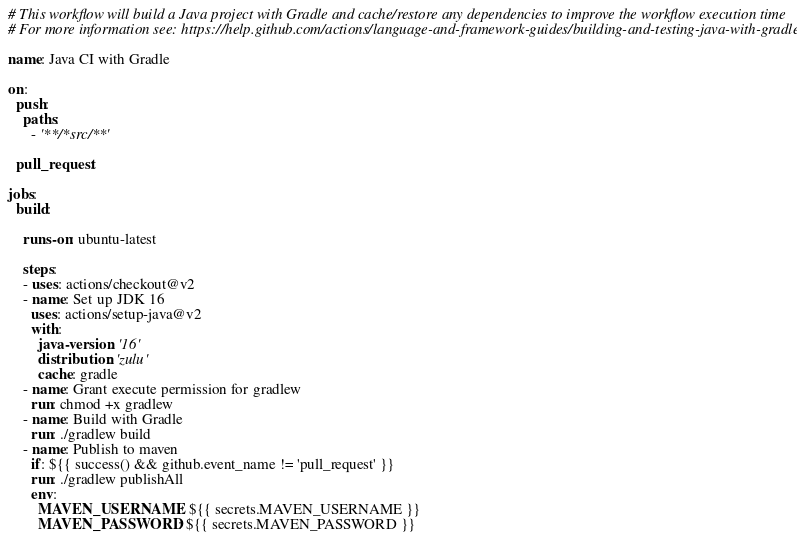Convert code to text. <code><loc_0><loc_0><loc_500><loc_500><_YAML_># This workflow will build a Java project with Gradle and cache/restore any dependencies to improve the workflow execution time
# For more information see: https://help.github.com/actions/language-and-framework-guides/building-and-testing-java-with-gradle

name: Java CI with Gradle

on:
  push:
    paths:
      - '**/*src/**'

  pull_request:

jobs:
  build:

    runs-on: ubuntu-latest

    steps:
    - uses: actions/checkout@v2
    - name: Set up JDK 16
      uses: actions/setup-java@v2
      with:
        java-version: '16'
        distribution: 'zulu'
        cache: gradle
    - name: Grant execute permission for gradlew
      run: chmod +x gradlew
    - name: Build with Gradle
      run: ./gradlew build
    - name: Publish to maven
      if: ${{ success() && github.event_name != 'pull_request' }}
      run: ./gradlew publishAll
      env:
        MAVEN_USERNAME: ${{ secrets.MAVEN_USERNAME }}
        MAVEN_PASSWORD: ${{ secrets.MAVEN_PASSWORD }}
</code> 